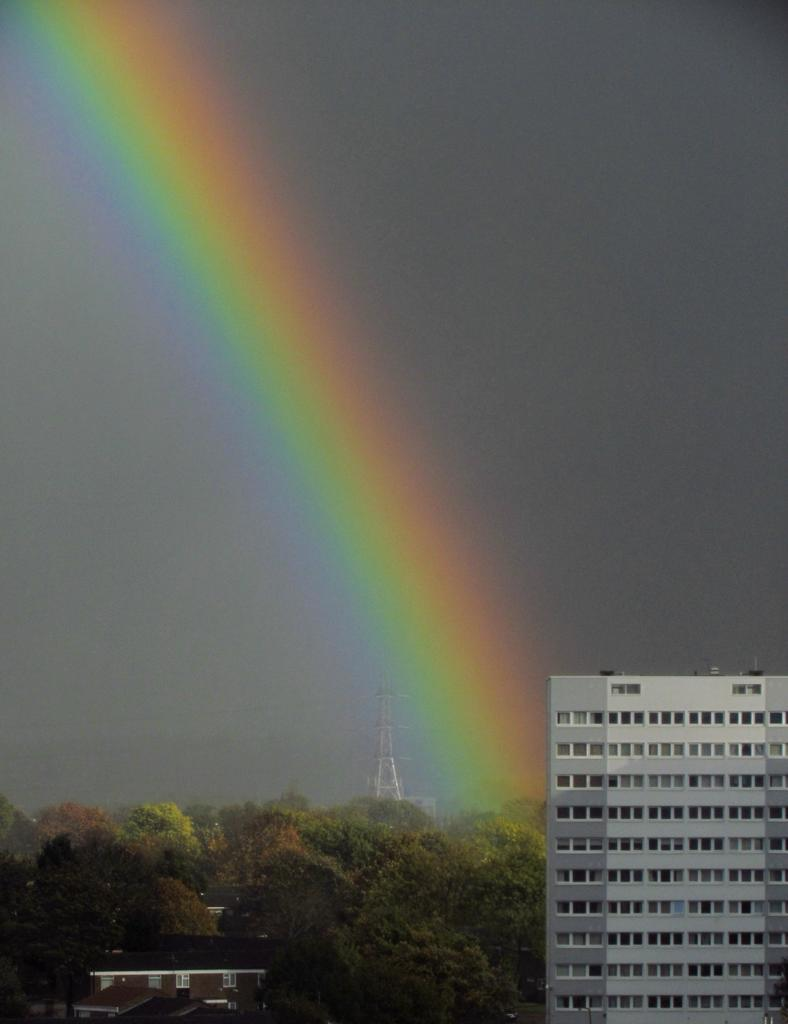What type of structures can be seen in the image? There are buildings and a tower in the image. What else is present in the image besides the structures? There are trees and a rainbow in the image. What is visible in the background of the image? The sky is visible in the image. Can you tell me how many stamps are on the tower in the image? There are no stamps present on the tower in the image. What type of fictional creature can be seen walking among the trees in the image? There are no fictional creatures present in the image; it features real-world elements such as buildings, a tower, trees, and a rainbow. 